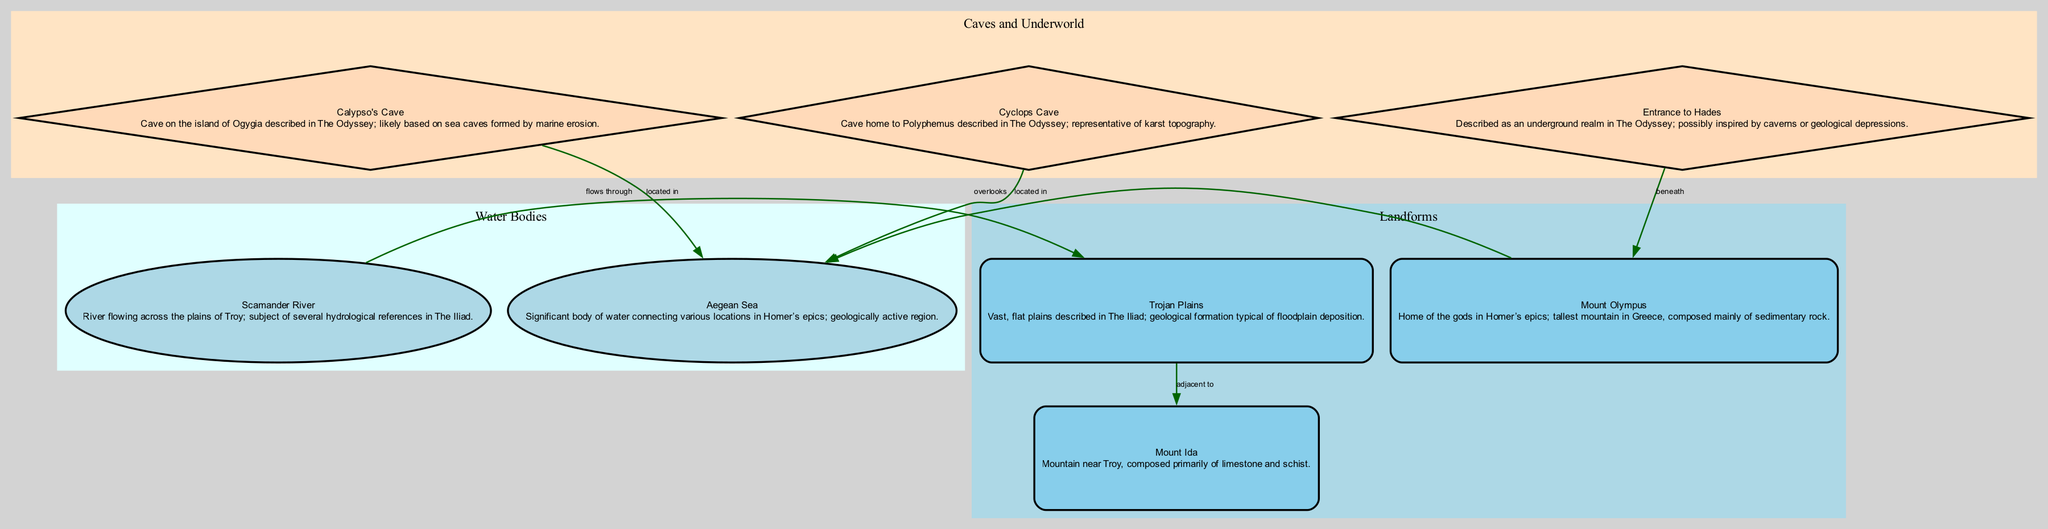What is the geological composition of Mount Ida? Mount Ida is described in the diagram as composed primarily of limestone and schist, which are common sedimentary and metamorphic rocks typically found in mountainous regions.
Answer: limestone and schist How many edges connect to the Aegean Sea? To find the answer, we look at the connections from other nodes in the diagram to the Aegean Sea. The edges show that there are three connections: Calypso's Cave, Cyclops' Cave, and Mount Olympus.
Answer: 3 What does the Scamander River do in relation to the Trojan Plains? According to the edges connecting the nodes, the Scamander River flows through the Trojan Plains, establishing its direct geographical relationship.
Answer: flows through Which cave is described as located in Ogygia? The diagram indicates that Calypso's Cave is specifically located on the island of Ogygia, which is mentioned in The Odyssey.
Answer: Calypso's Cave What type of topography is represented by Cyclops' Cave? The diagram describes Cyclops' Cave as representative of karst topography, a geological formation created from the dissolution of soluble rocks such as limestone.
Answer: karst topography What geological feature is directly beneath Mount Olympus? The entrance to Hades is described in the diagram as being beneath Mount Olympus, linking the two in a spatial and mythological context.
Answer: Entrance to Hades Which landform is adjacent to the Trojan Plains? Referring to the edges in the diagram, Mount Ida is identified as being adjacent to the Trojan Plains, indicating a close geographical relationship.
Answer: Mount Ida What natural feature overlooks the Aegean Sea? The diagram specifies that Mount Olympus overlooks the Aegean Sea, establishing a prominent geographical feature in relation to the body of water.
Answer: Mount Olympus How is the Calypso's Cave formed? The description states that Calypso's Cave is likely based on sea caves formed by marine erosion, highlighting the process that leads to its creation.
Answer: marine erosion 